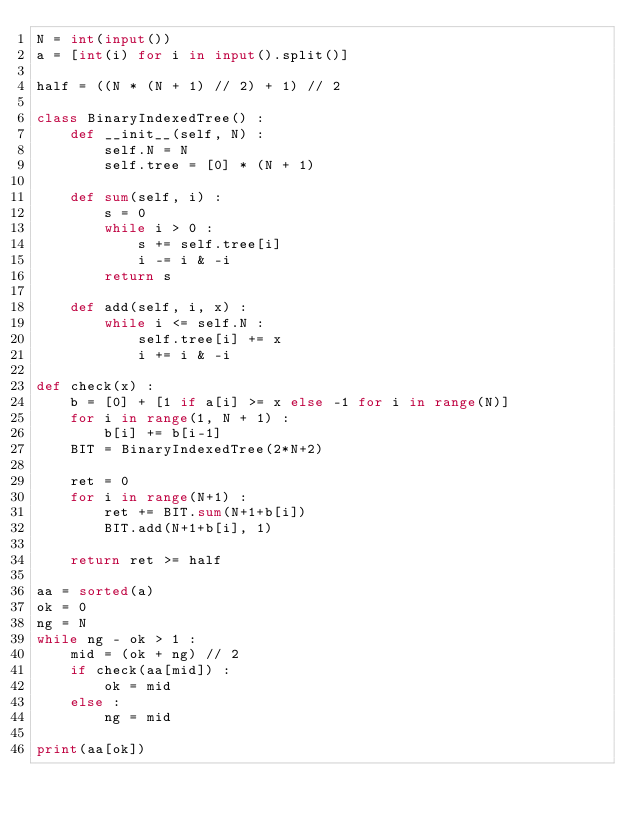Convert code to text. <code><loc_0><loc_0><loc_500><loc_500><_Python_>N = int(input())
a = [int(i) for i in input().split()]

half = ((N * (N + 1) // 2) + 1) // 2

class BinaryIndexedTree() :
    def __init__(self, N) :
        self.N = N
        self.tree = [0] * (N + 1)
        
    def sum(self, i) :
        s = 0
        while i > 0 :
            s += self.tree[i]
            i -= i & -i
        return s
        
    def add(self, i, x) :
        while i <= self.N :
            self.tree[i] += x
            i += i & -i

def check(x) :
    b = [0] + [1 if a[i] >= x else -1 for i in range(N)]
    for i in range(1, N + 1) :
        b[i] += b[i-1]
    BIT = BinaryIndexedTree(2*N+2)
    
    ret = 0
    for i in range(N+1) :
        ret += BIT.sum(N+1+b[i])
        BIT.add(N+1+b[i], 1)
    
    return ret >= half
    
aa = sorted(a)
ok = 0
ng = N
while ng - ok > 1 :
    mid = (ok + ng) // 2
    if check(aa[mid]) :
        ok = mid
    else :
        ng = mid

print(aa[ok])
    </code> 